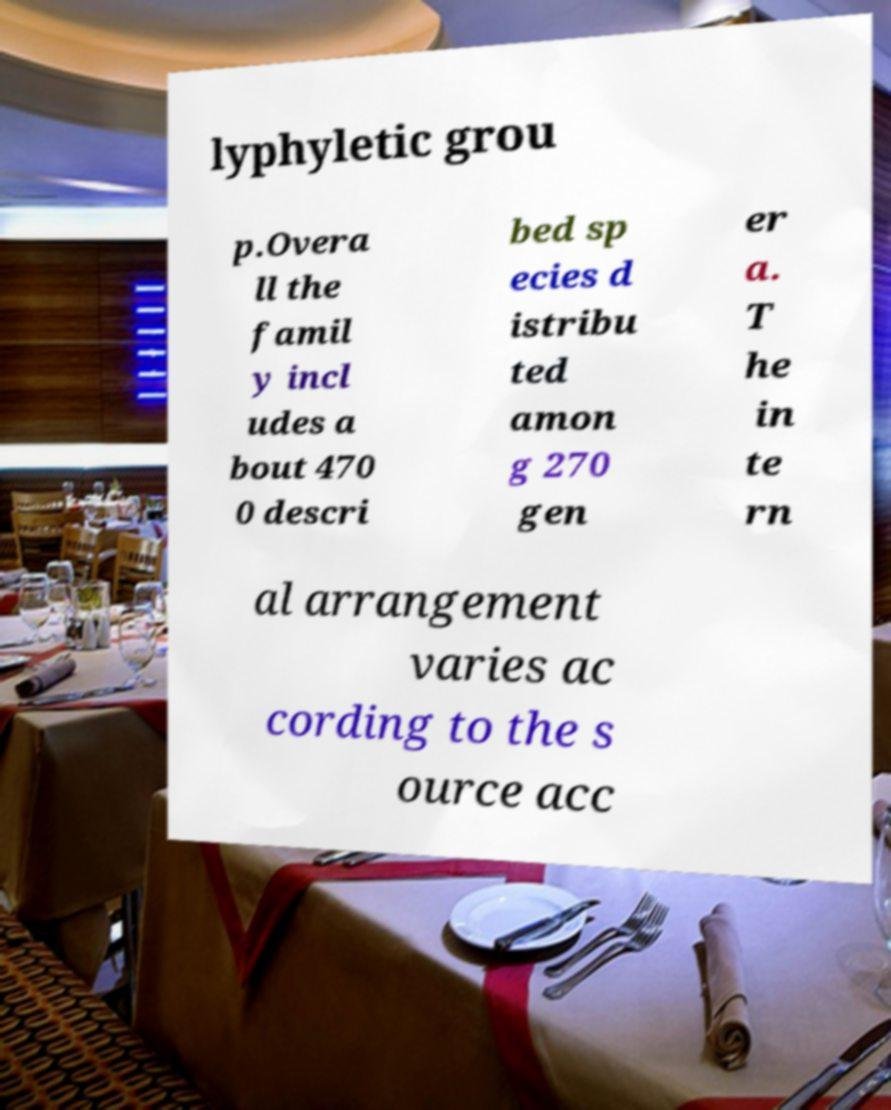For documentation purposes, I need the text within this image transcribed. Could you provide that? lyphyletic grou p.Overa ll the famil y incl udes a bout 470 0 descri bed sp ecies d istribu ted amon g 270 gen er a. T he in te rn al arrangement varies ac cording to the s ource acc 